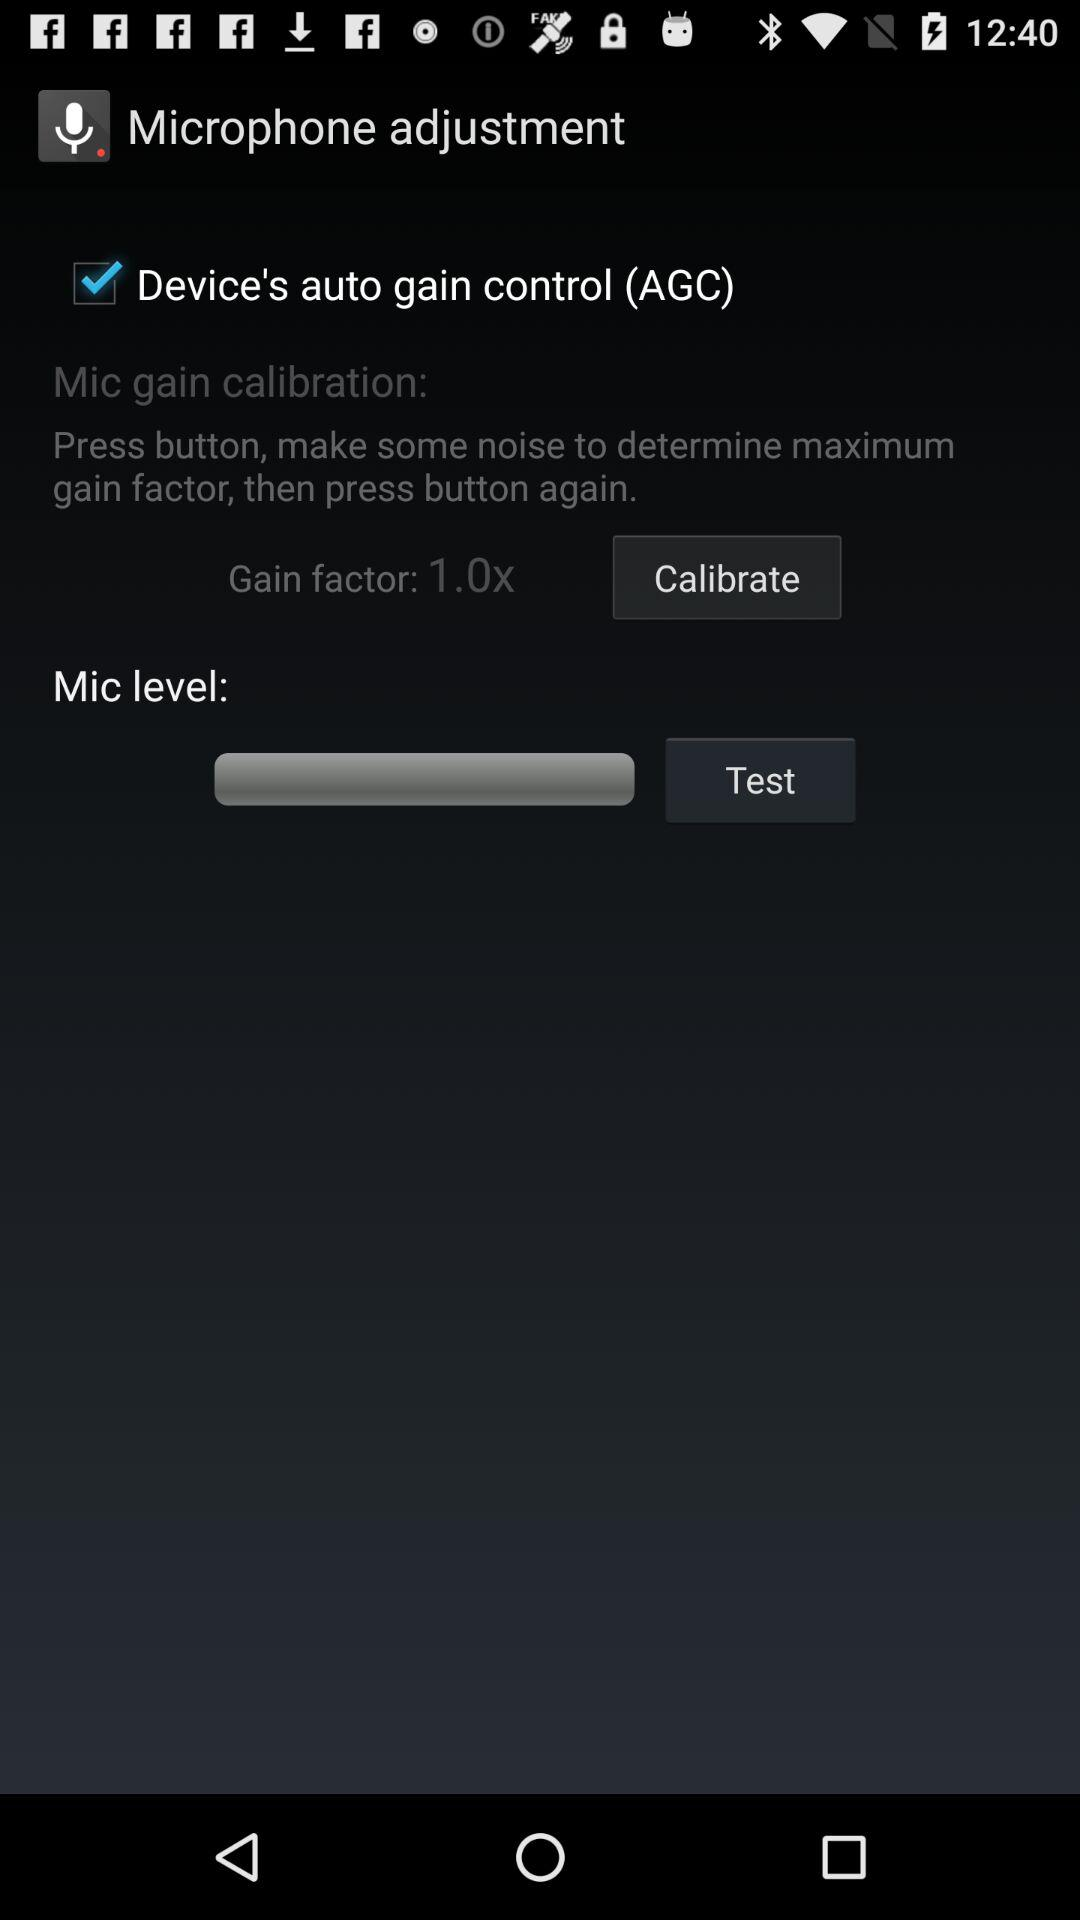What is the mic level?
When the provided information is insufficient, respond with <no answer>. <no answer> 